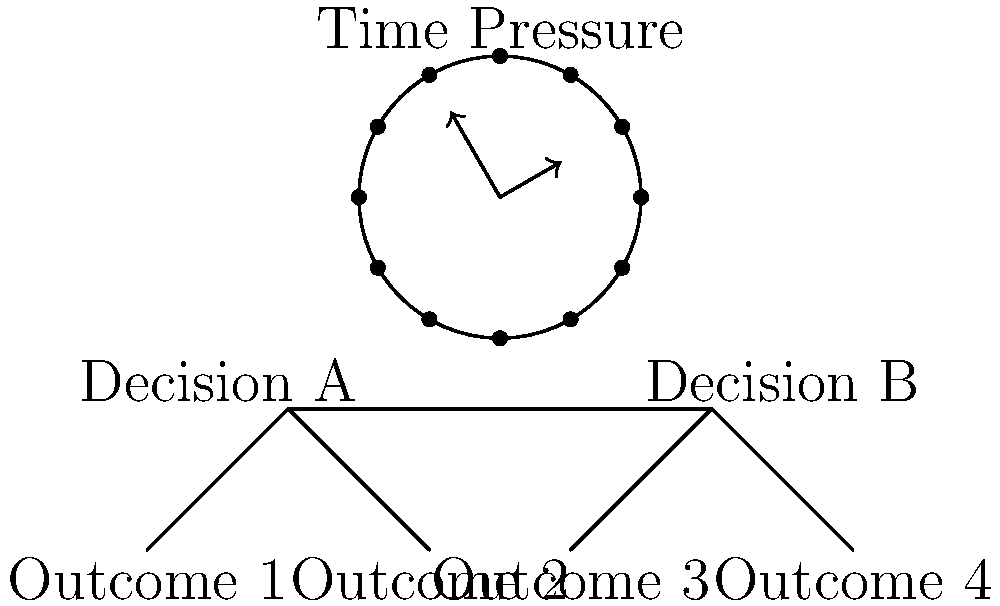Based on the diagram, which illustrates the influence of time pressure on group decision-making, what is the most likely effect of increased time pressure on the quality and thoroughness of group decisions? To answer this question, let's analyze the diagram and consider the implications of time pressure on group decision-making:

1. The clock in the diagram indicates time pressure, with the hands pointing towards a deadline.

2. The decision tree below shows two main decisions (A and B) with multiple outcomes for each.

3. Time pressure typically affects decision-making processes in the following ways:
   a) Reduces the amount of time available for information gathering and analysis.
   b) Limits the opportunity for thorough discussion and debate among group members.
   c) Increases stress and anxiety, which can impair cognitive functions.

4. With limited time, groups are more likely to:
   a) Focus on readily available information rather than seeking additional data.
   b) Rely more on heuristics or shortcuts in decision-making.
   c) Consider fewer alternatives or outcomes.

5. The decision tree in the diagram shows multiple outcomes for each decision, but under time pressure, groups might not fully explore all these possibilities.

6. Research in social psychology and group dynamics suggests that time pressure often leads to:
   a) More rapid decision-making but potentially at the cost of accuracy.
   b) Increased likelihood of groupthink, where dissenting opinions are suppressed.
   c) Greater reliance on dominant group members or leaders.

7. The combination of the clock and decision tree in the diagram implies that as time pressure increases (clock hands moving closer to a deadline), the ability to thoroughly examine all branches of the decision tree decreases.

Given these factors, the most likely effect of increased time pressure on the quality and thoroughness of group decisions is a decrease in both quality and thoroughness.
Answer: Decreased quality and thoroughness of decisions 